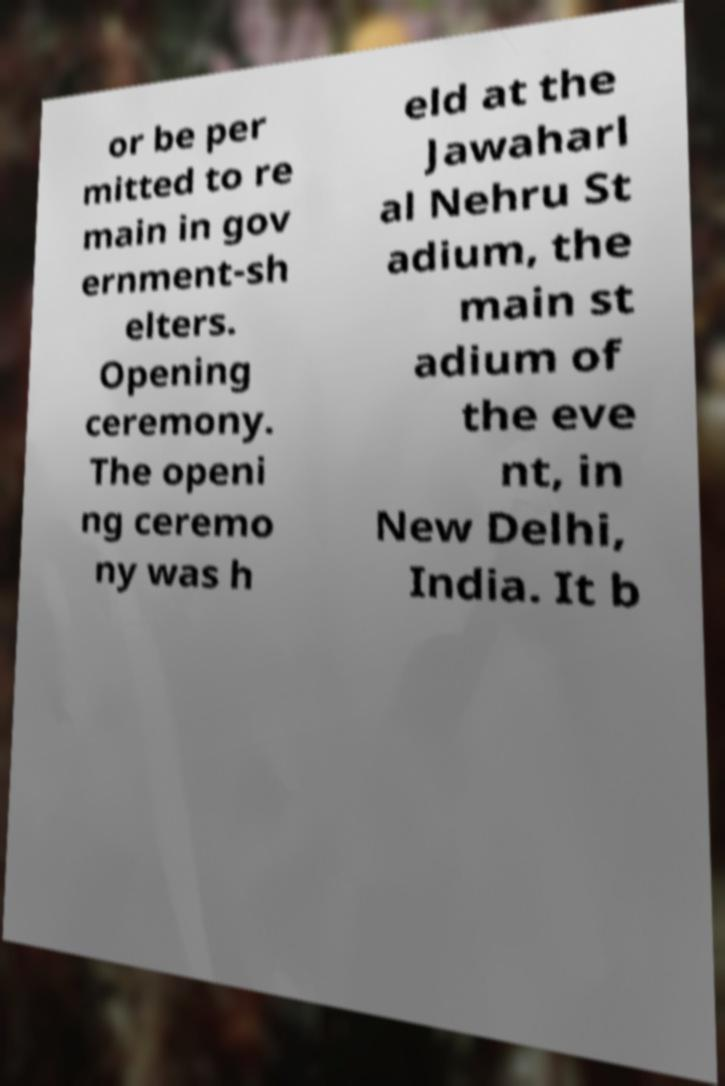Can you read and provide the text displayed in the image?This photo seems to have some interesting text. Can you extract and type it out for me? or be per mitted to re main in gov ernment-sh elters. Opening ceremony. The openi ng ceremo ny was h eld at the Jawaharl al Nehru St adium, the main st adium of the eve nt, in New Delhi, India. It b 